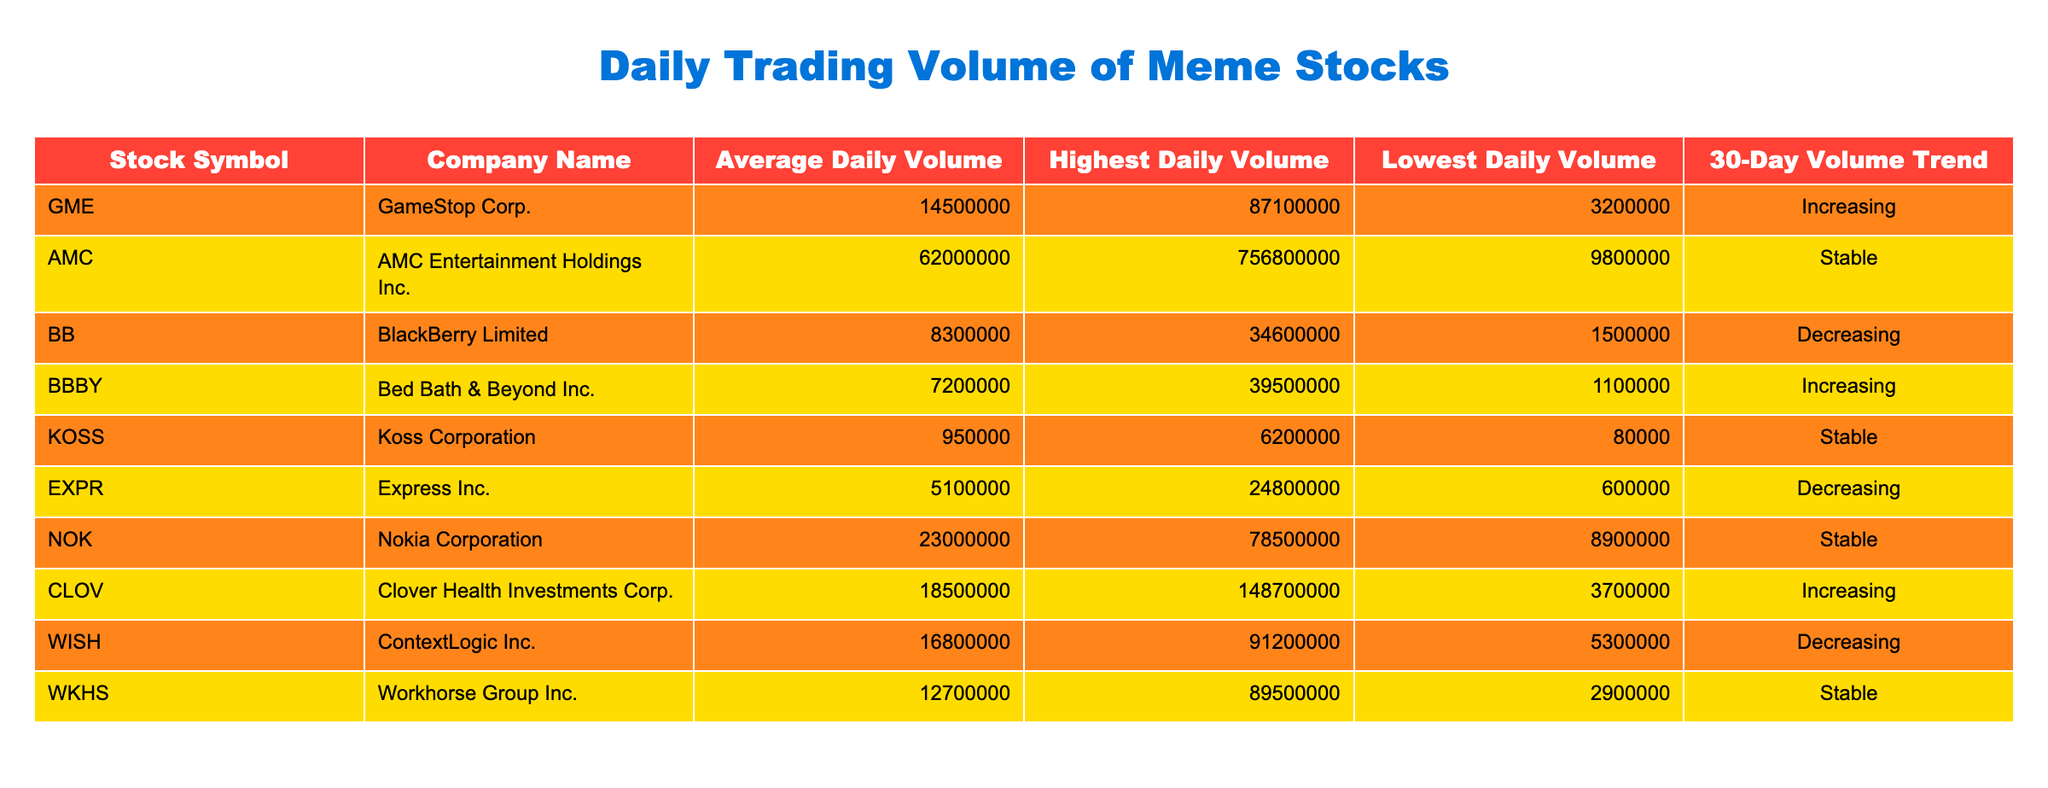What is the average daily volume of GameStop Corp.? From the table, the Average Daily Volume for GameStop Corp. (GME) is listed as 14,500,000.
Answer: 14,500,000 Which stock has the highest daily volume recorded? By reviewing the Highest Daily Volume column, AMC Entertainment (AMC) has the highest value at 756,800,000.
Answer: AMC Entertainment (AMC) Is the 30-day volume trend for Koss Corporation increasing? Checking the 30-Day Volume Trend column, Koss Corporation (KOSS) shows a trend of Stable, which means it is neither increasing nor decreasing.
Answer: No What is the difference between the Average Daily Volume of Nokia Corporation and BlackBerry Limited? The Average Daily Volume for Nokia (23,000,000) minus BlackBerry (8,300,000) is 23,000,000 - 8,300,000 = 14,700,000.
Answer: 14,700,000 Does Bed Bath & Beyond Inc. have a higher Average Daily Volume than Express Inc.? Bed Bath & Beyond (BBBY) has an Average Daily Volume of 7,200,000 and Express Inc. (EXPR) has 5,100,000, therefore BBBY is higher.
Answer: Yes Which two stocks have an increasing 30-day volume trend? Referring to the 30-Day Volume Trend column, GameStop (GME) and Bed Bath & Beyond (BBBY) have an increasing trend.
Answer: GameStop (GME), Bed Bath & Beyond (BBBY) What is the total Average Daily Volume of all stocks listed in the table? To find the total, sum all Average Daily Volumes: 14,500,000 + 62,000,000 + 8,300,000 + 7,200,000 + 950,000 + 5,100,000 + 23,000,000 + 18,500,000 + 16,800,000 + 12,700,000 = 169,000,000.
Answer: 169,000,000 Which stock has both the highest and lowest daily volume recorded from this selection? By examining the Highest and Lowest Daily Volume columns, AMC has the highest at 756,800,000, while Koss Corporation has the lowest at 80,000.
Answer: AMC (highest), Koss Corporation (lowest) Is AMC the only stock with a Stable volume trend? Checking the 30-Day Volume Trend, there are multiple stocks with Stable trends: KOSS, NOK, and WKHS. Thus, AMC is not the only one.
Answer: No 